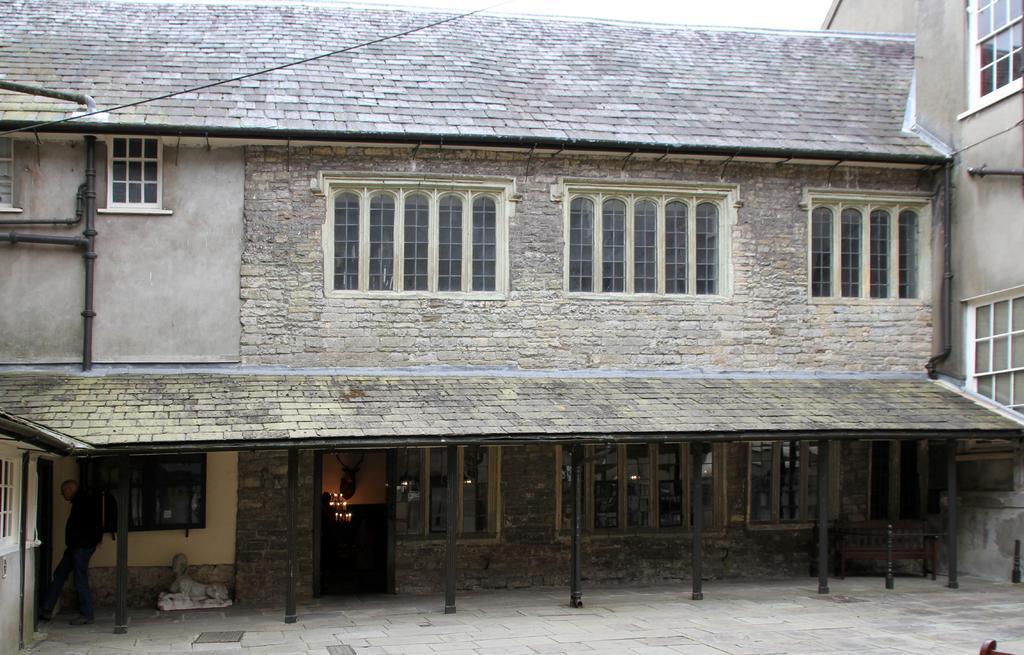Can you describe this image briefly? In this picture I can see a building and I can see few glass windows and a cloudy sky. 